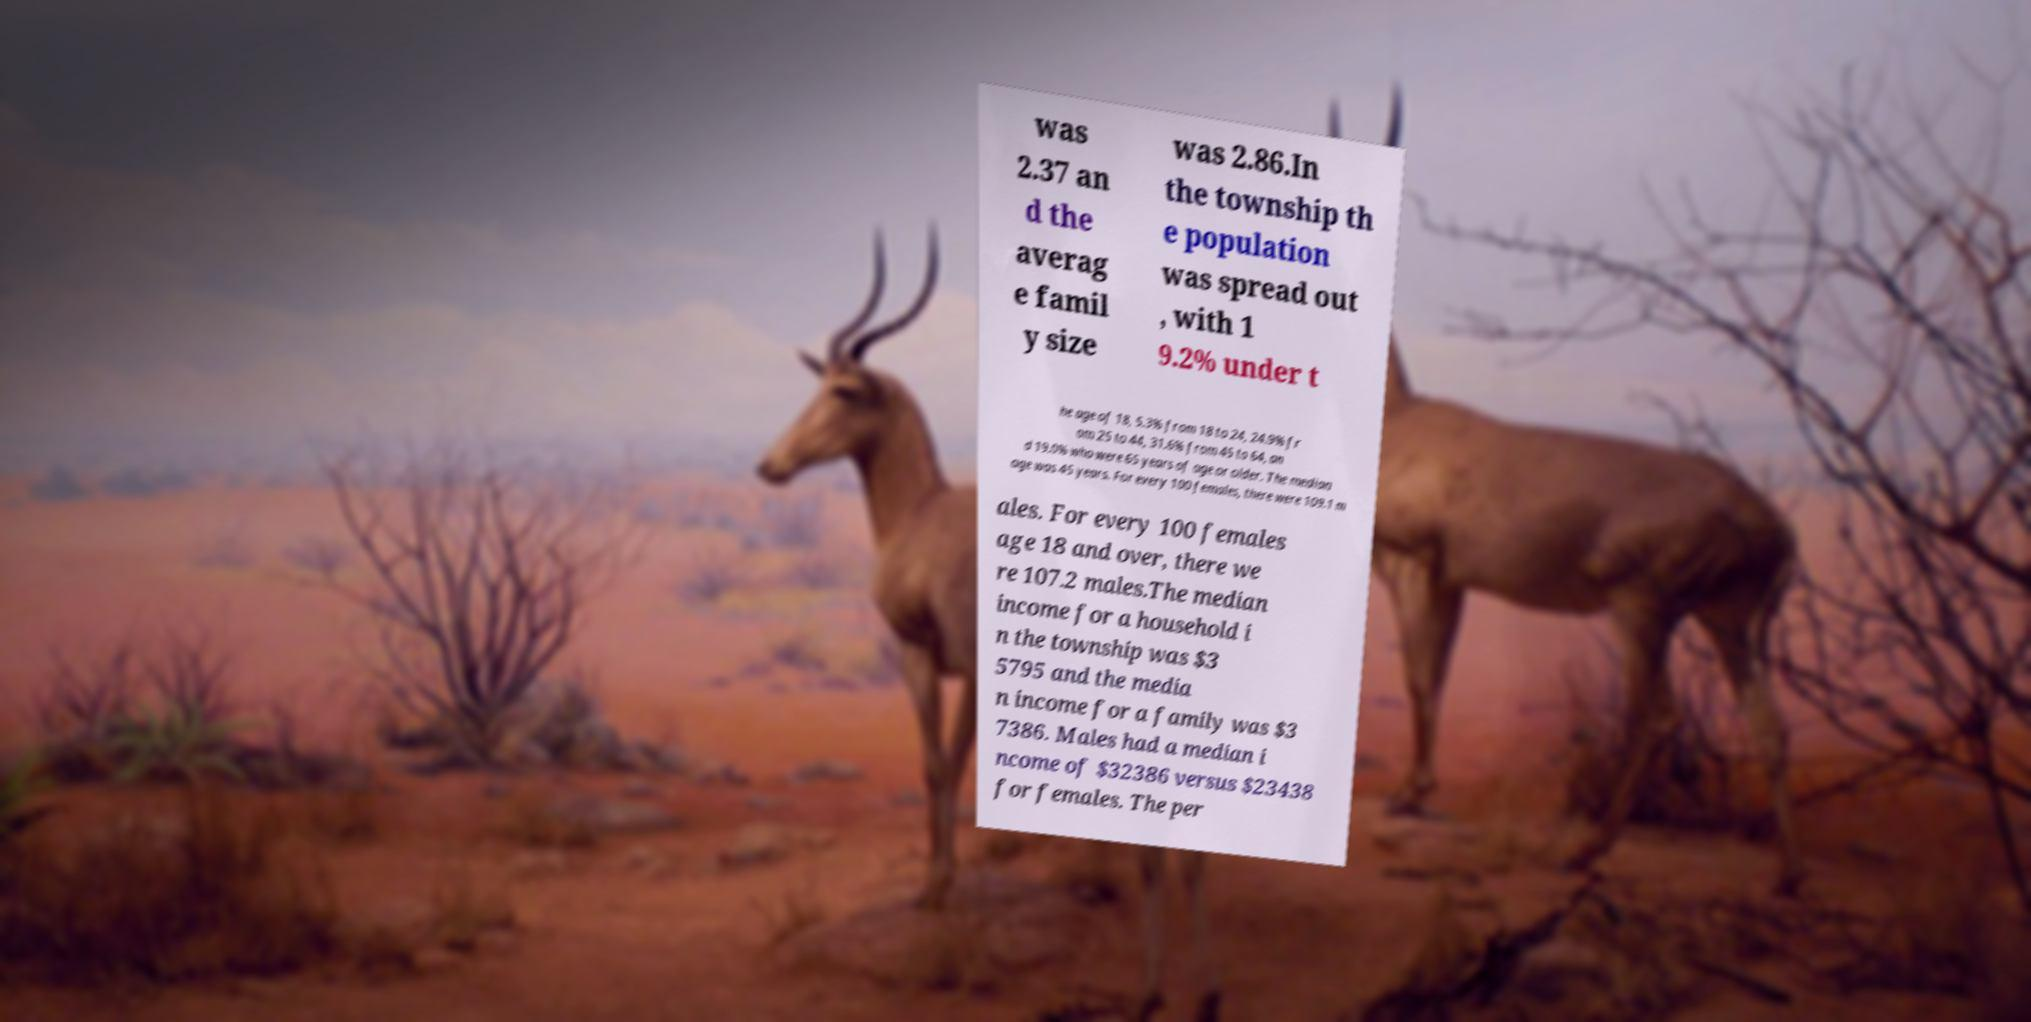Please identify and transcribe the text found in this image. was 2.37 an d the averag e famil y size was 2.86.In the township th e population was spread out , with 1 9.2% under t he age of 18, 5.3% from 18 to 24, 24.9% fr om 25 to 44, 31.6% from 45 to 64, an d 19.0% who were 65 years of age or older. The median age was 45 years. For every 100 females, there were 109.1 m ales. For every 100 females age 18 and over, there we re 107.2 males.The median income for a household i n the township was $3 5795 and the media n income for a family was $3 7386. Males had a median i ncome of $32386 versus $23438 for females. The per 